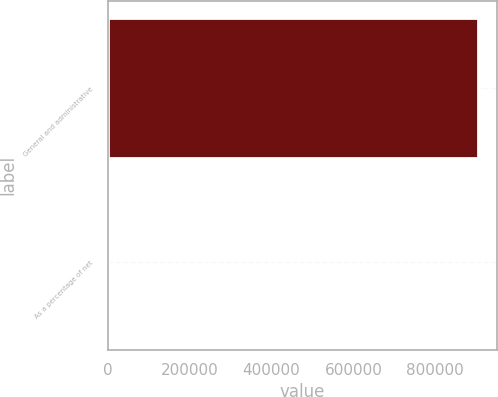<chart> <loc_0><loc_0><loc_500><loc_500><bar_chart><fcel>General and administrative<fcel>As a percentage of net<nl><fcel>904681<fcel>11.8<nl></chart> 